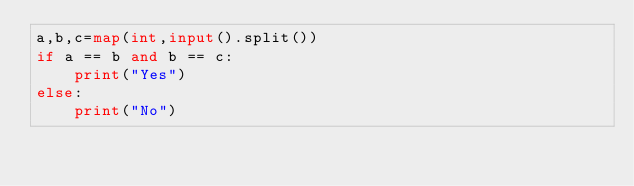<code> <loc_0><loc_0><loc_500><loc_500><_Python_>a,b,c=map(int,input().split())
if a == b and b == c:
    print("Yes")
else:
    print("No")
</code> 